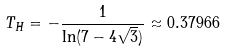<formula> <loc_0><loc_0><loc_500><loc_500>T _ { H } = - \frac { 1 } { \ln ( 7 - 4 \sqrt { 3 } ) } \approx 0 . 3 7 9 6 6</formula> 